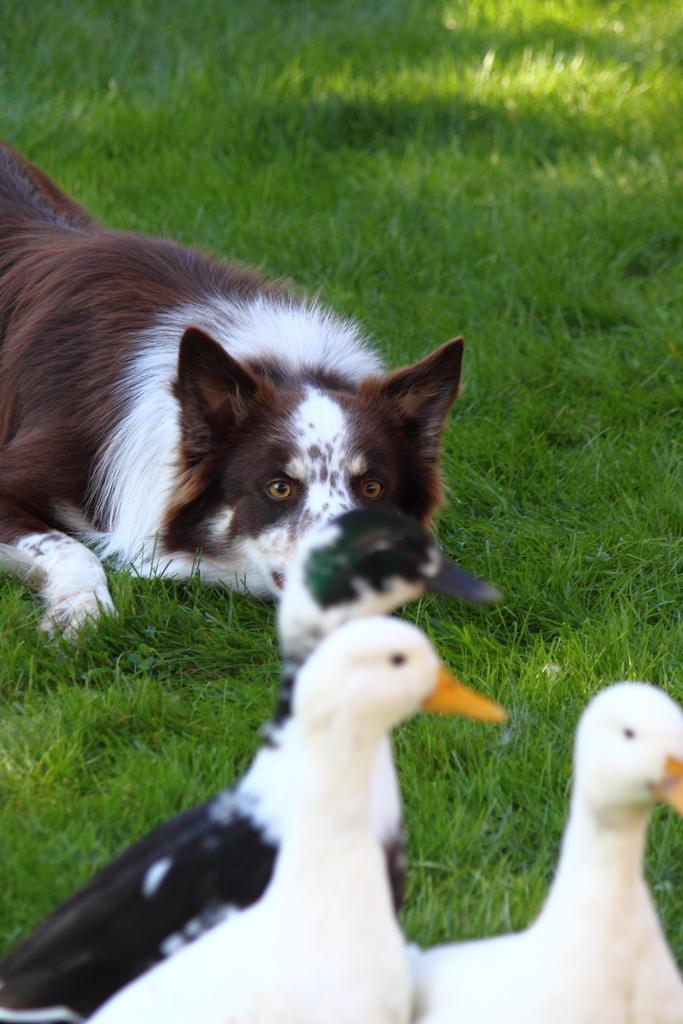What animal can be seen in the image? There is a dog in the image. Where is the dog located? The dog is lying on the grass. How many ducks are in the image? There are three ducks in the image. What colors are the ducks? One of the ducks is black, and two of the ducks are white. What type of thread is being used to sew the patch onto the dog's fur in the image? There is no thread or patch present in the image; it only features a dog lying on the grass and three ducks. 